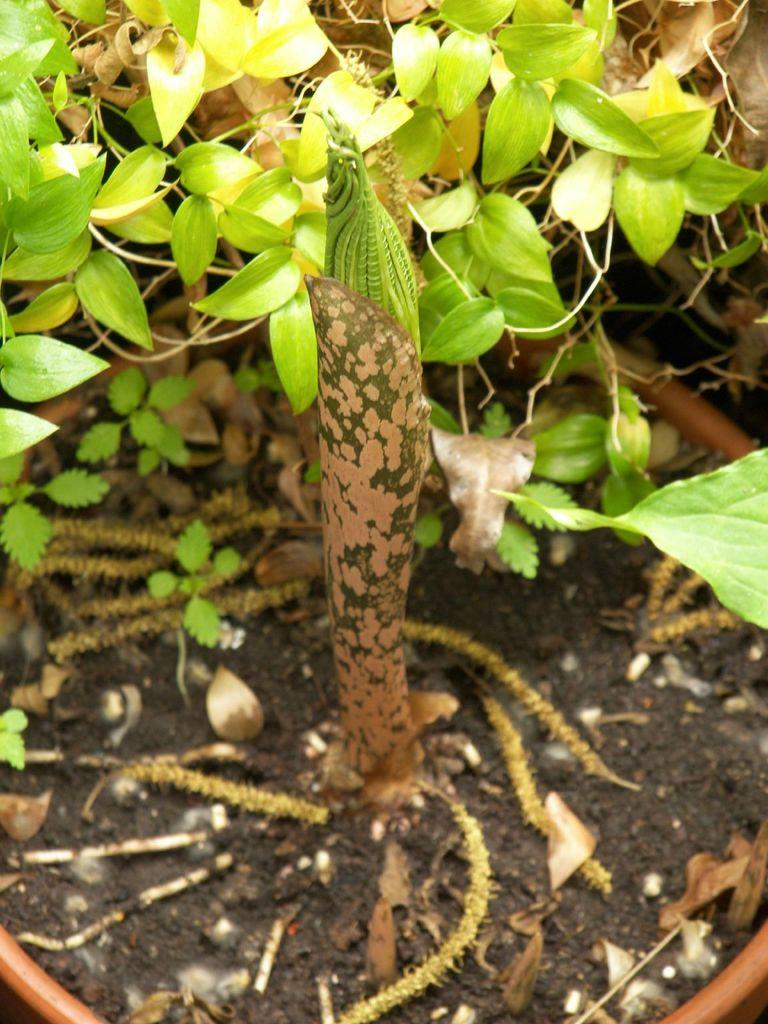What type of living organisms can be seen in the image? Plants can be seen in the image. Can you describe a specific part of the plants in the image? There is a group of leaves in the image. What type of noise can be heard coming from the art in the image? There is no art or noise present in the image; it features plants and a group of leaves. 